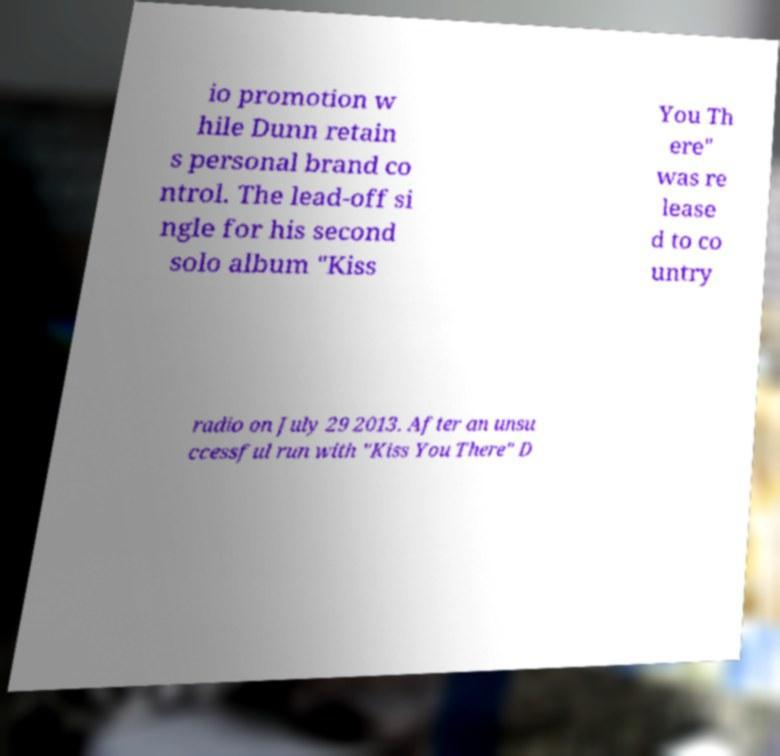Please identify and transcribe the text found in this image. io promotion w hile Dunn retain s personal brand co ntrol. The lead-off si ngle for his second solo album "Kiss You Th ere" was re lease d to co untry radio on July 29 2013. After an unsu ccessful run with "Kiss You There" D 